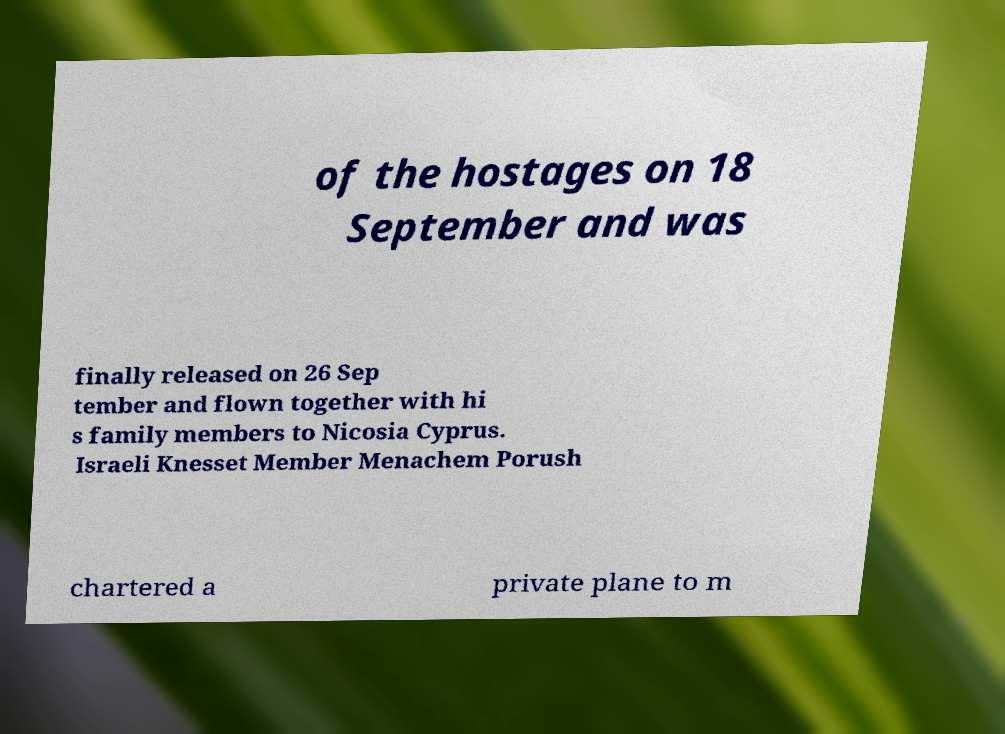Could you assist in decoding the text presented in this image and type it out clearly? of the hostages on 18 September and was finally released on 26 Sep tember and flown together with hi s family members to Nicosia Cyprus. Israeli Knesset Member Menachem Porush chartered a private plane to m 